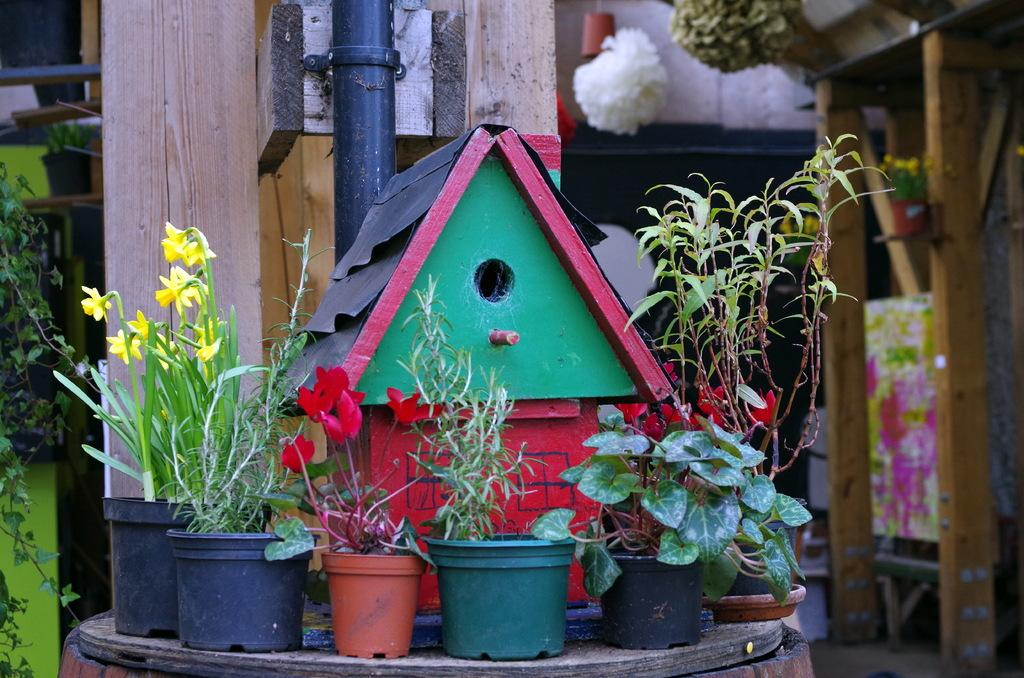What type of structure is present in the image? There is a bird house in the image. What else can be seen in the image besides the bird house? There are flower pots with plants in the image. How are the flower pots positioned? The flower pots are placed on an object. What can be seen in the background of the image? There is a pipe visible in the background of the image, along with other objects. How many servants are attending to the bird house in the image? There are no servants present in the image; it features a bird house, flower pots, and other objects. What type of cemetery can be seen in the background of the image? There is no cemetery present in the image; it features a bird house, flower pots, a pipe, and other objects in the background. 